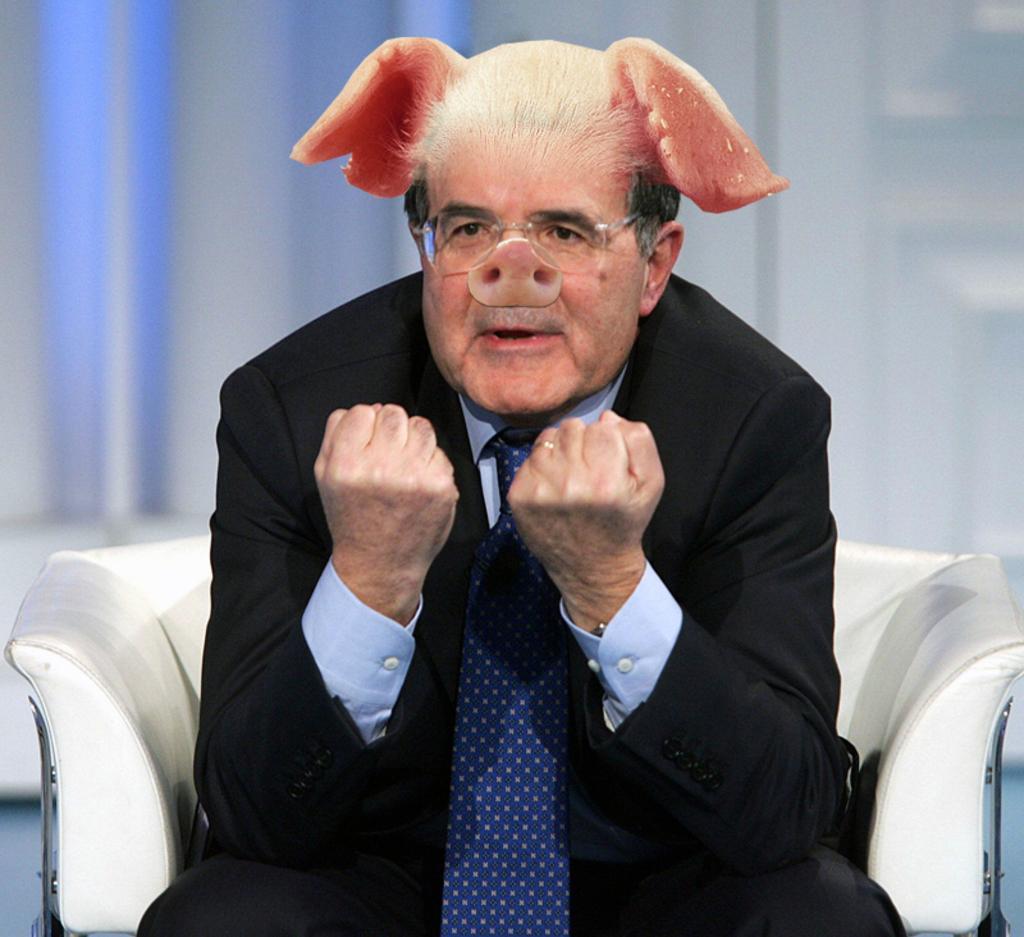Could you give a brief overview of what you see in this image? In this image we can see a man sitting on the couch and wearing the mask of pig's nose and ears. 